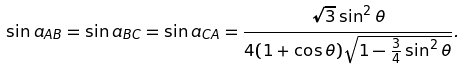<formula> <loc_0><loc_0><loc_500><loc_500>\sin a _ { A B } = \sin a _ { B C } = \sin a _ { C A } = \frac { \sqrt { 3 } \sin ^ { 2 } \theta } { 4 ( 1 + \cos \theta ) \sqrt { 1 - \frac { 3 } { 4 } \sin ^ { 2 } \theta } } .</formula> 